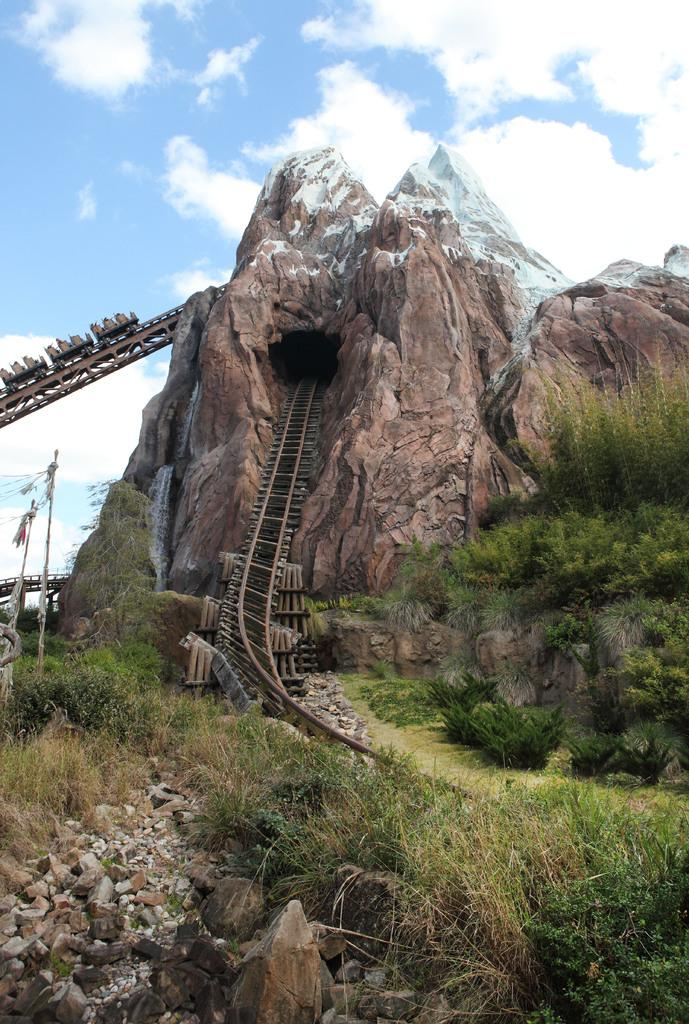What can be seen in the foreground of the picture? There are shrubs and stones in the foreground of the picture. What is the main feature in the center of the picture? There is a mountain in the center of the picture, and there is also a railway track. What is the weather like in the picture? The sky is sunny, indicating a clear and bright day. What type of discussion is taking place between the toes in the picture? There are no toes or discussion present in the picture. The image features a mountain, a railway track, and a sunny sky. 